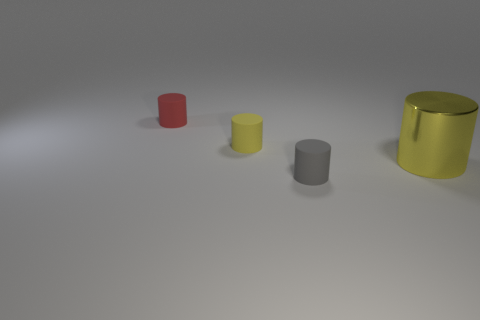Add 1 tiny yellow things. How many objects exist? 5 Subtract 0 yellow blocks. How many objects are left? 4 Subtract all cyan rubber balls. Subtract all gray rubber cylinders. How many objects are left? 3 Add 3 gray rubber objects. How many gray rubber objects are left? 4 Add 2 gray cylinders. How many gray cylinders exist? 3 